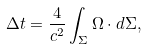Convert formula to latex. <formula><loc_0><loc_0><loc_500><loc_500>\Delta t = \frac { 4 } { c ^ { 2 } } \int _ { \Sigma } { \Omega } \cdot d { \Sigma } ,</formula> 